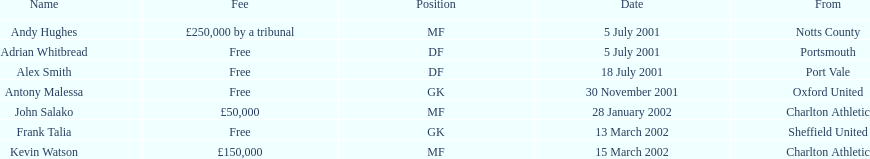What is the total number of free fees? 4. 